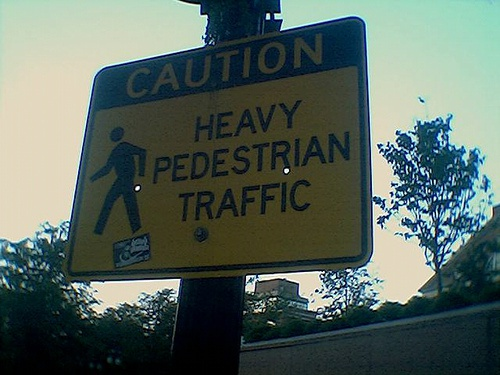Describe the objects in this image and their specific colors. I can see people in turquoise, black, and darkblue tones in this image. 